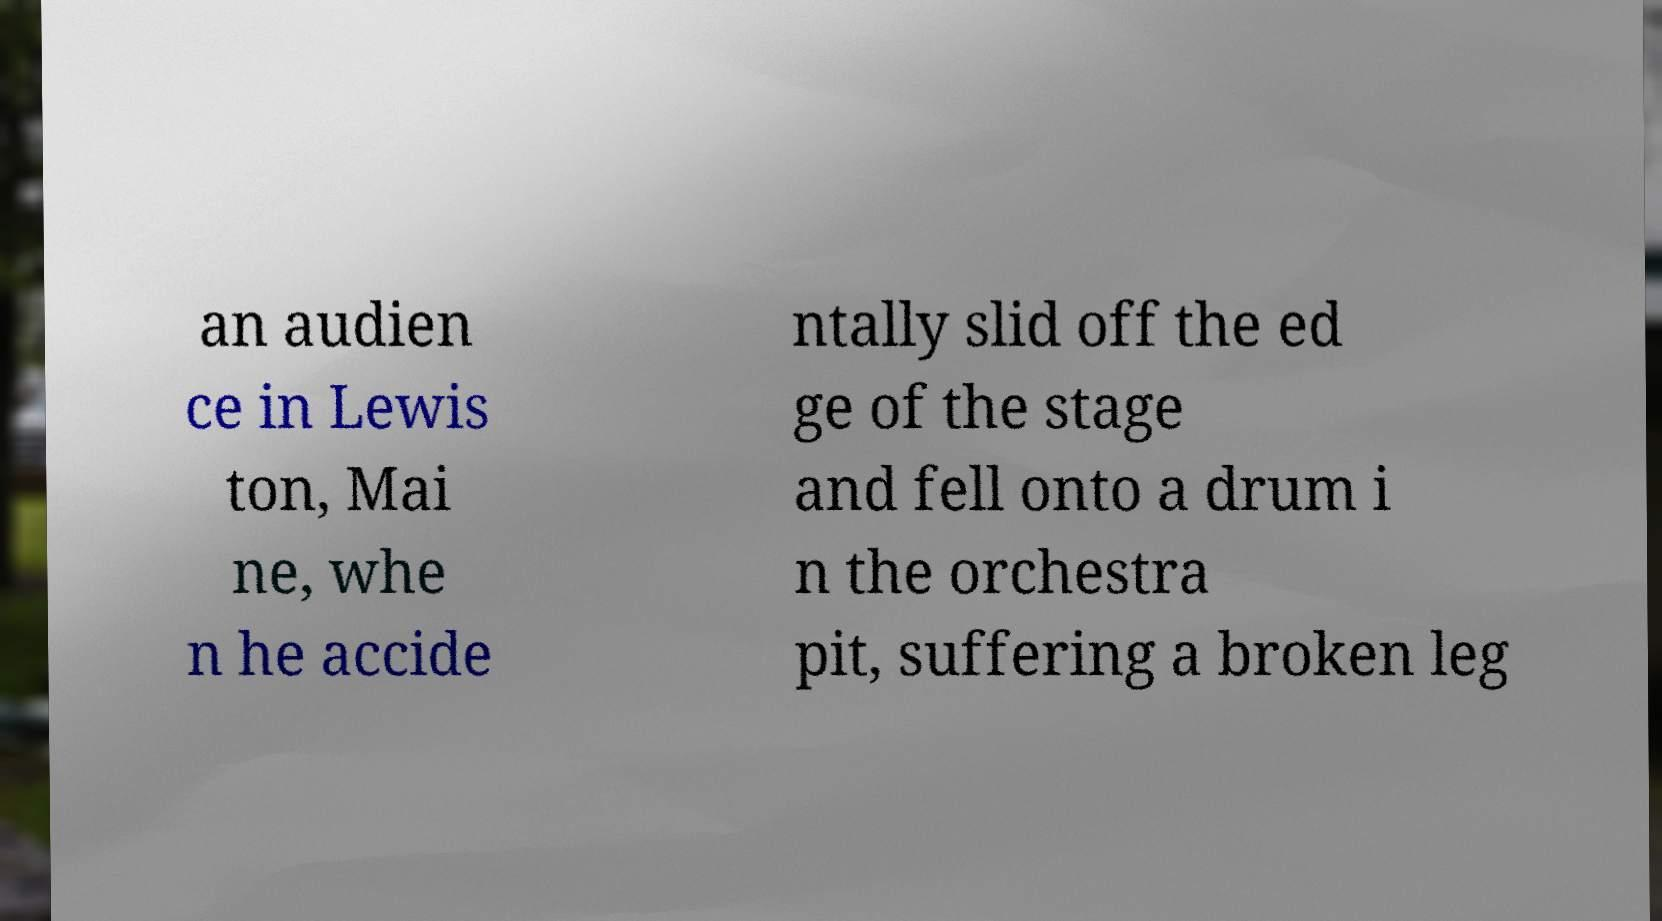For documentation purposes, I need the text within this image transcribed. Could you provide that? an audien ce in Lewis ton, Mai ne, whe n he accide ntally slid off the ed ge of the stage and fell onto a drum i n the orchestra pit, suffering a broken leg 